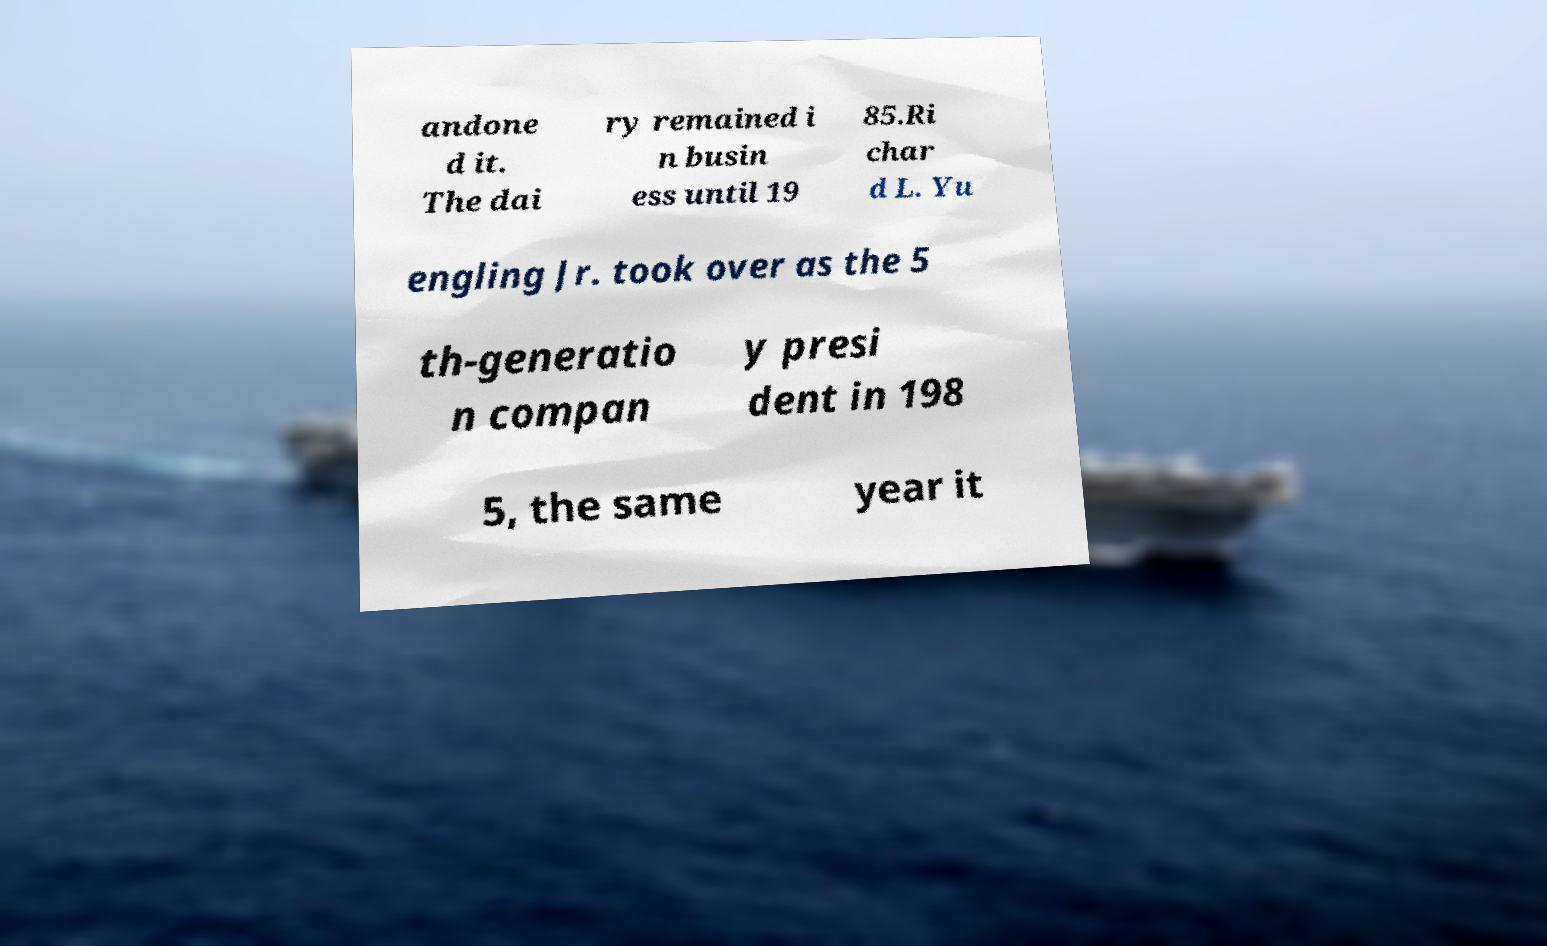Please read and relay the text visible in this image. What does it say? andone d it. The dai ry remained i n busin ess until 19 85.Ri char d L. Yu engling Jr. took over as the 5 th-generatio n compan y presi dent in 198 5, the same year it 